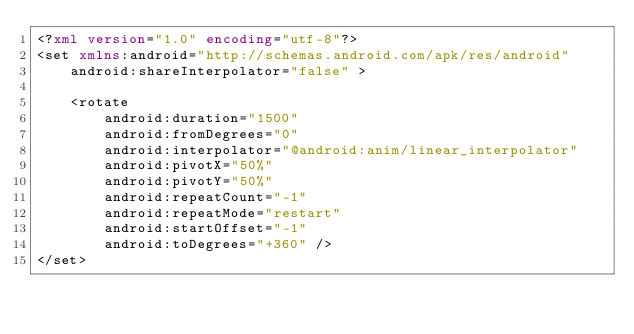Convert code to text. <code><loc_0><loc_0><loc_500><loc_500><_XML_><?xml version="1.0" encoding="utf-8"?>
<set xmlns:android="http://schemas.android.com/apk/res/android"
    android:shareInterpolator="false" >

    <rotate
        android:duration="1500"
        android:fromDegrees="0"
        android:interpolator="@android:anim/linear_interpolator"
        android:pivotX="50%"
        android:pivotY="50%"
        android:repeatCount="-1"
        android:repeatMode="restart"
        android:startOffset="-1"
        android:toDegrees="+360" />
</set></code> 